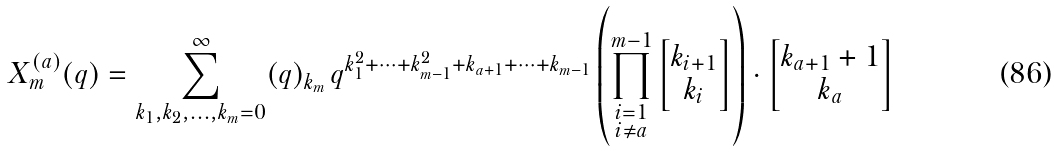Convert formula to latex. <formula><loc_0><loc_0><loc_500><loc_500>X _ { m } ^ { ( a ) } ( q ) = \sum _ { k _ { 1 } , k _ { 2 } , \dots , k _ { m } = 0 } ^ { \infty } ( q ) _ { k _ { m } } \, q ^ { k _ { 1 } ^ { 2 } + \dots + k _ { m - 1 } ^ { 2 } + k _ { a + 1 } + \dots + k _ { m - 1 } } \left ( \prod _ { \substack { i = 1 \\ i \neq a } } ^ { m - 1 } \begin{bmatrix} k _ { i + 1 } \\ k _ { i } \end{bmatrix} \right ) \cdot \begin{bmatrix} k _ { a + 1 } + 1 \\ k _ { a } \end{bmatrix}</formula> 